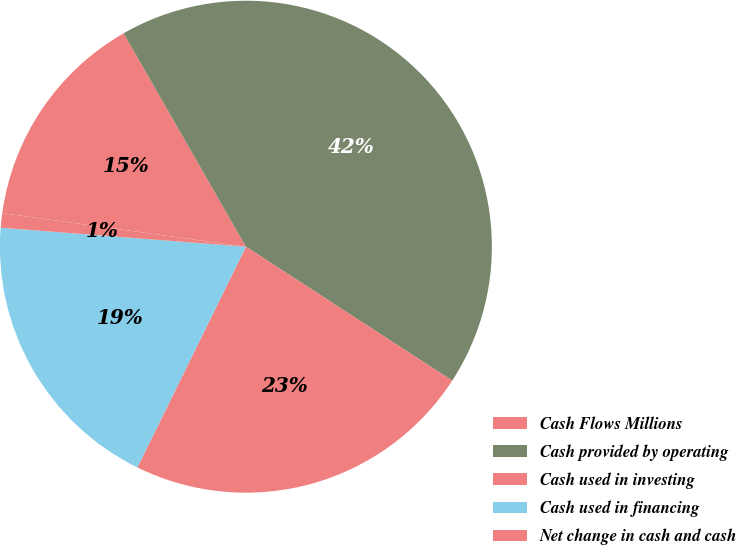<chart> <loc_0><loc_0><loc_500><loc_500><pie_chart><fcel>Cash Flows Millions<fcel>Cash provided by operating<fcel>Cash used in investing<fcel>Cash used in financing<fcel>Net change in cash and cash<nl><fcel>14.54%<fcel>42.45%<fcel>23.11%<fcel>18.96%<fcel>0.95%<nl></chart> 